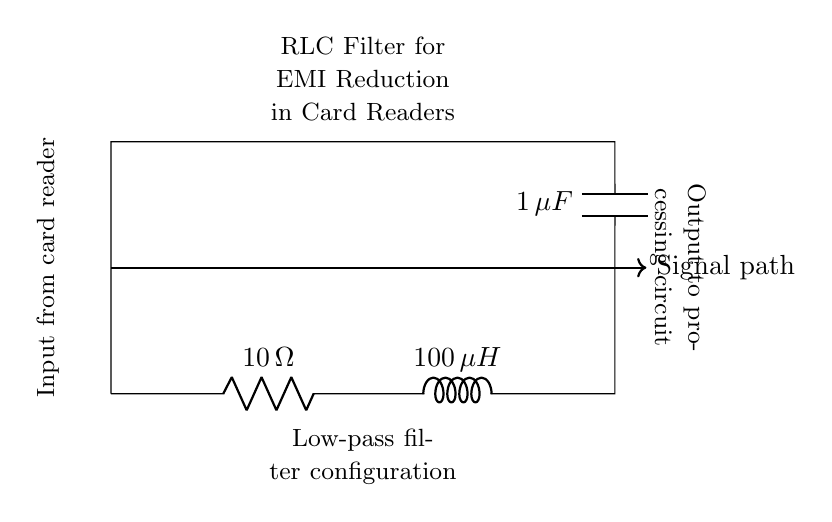What is the resistance value in the circuit? The resistance value is specified as 10 ohms, which is indicated next to the resistor component in the diagram.
Answer: 10 ohms What is the inductance value of the inductor? The inductance value is given as 100 microhenries, which can be found next to the inductor symbol in the circuit.
Answer: 100 microhenries What type of filter configuration is shown in the diagram? The diagram depicts a low-pass filter configuration, indicated by the arrangement of the resistor, inductor, and capacitor which allows low-frequency signals to pass through while attenuating high-frequency signals.
Answer: Low-pass filter What is the capacitance value in the circuit? The capacitance value is stated as 1 microfarad, mentioned adjacent to the capacitor component in the drawn circuit.
Answer: 1 microfarad How do the components affect electromagnetic interference reduction? The resistor, inductor, and capacitor work together to form an RLC filter, which helps to reduce electromagnetic interference by filtering out unwanted high-frequency noise from the signal passing through the card reader.
Answer: By filtering What is the significance of the signal path in this circuit? The signal path represents the route through which the electrical signal from the card reader travels, and is crucial in determining how effectively the circuit can filter out unwanted noise while allowing the desired signal to pass.
Answer: It represents the route of the signal What happens to high-frequency signals in this circuit? The high-frequency signals are attenuated or reduced significantly by the combination of the resistor, inductor, and capacitor, making the circuit effective for EMI reduction.
Answer: They are attenuated 